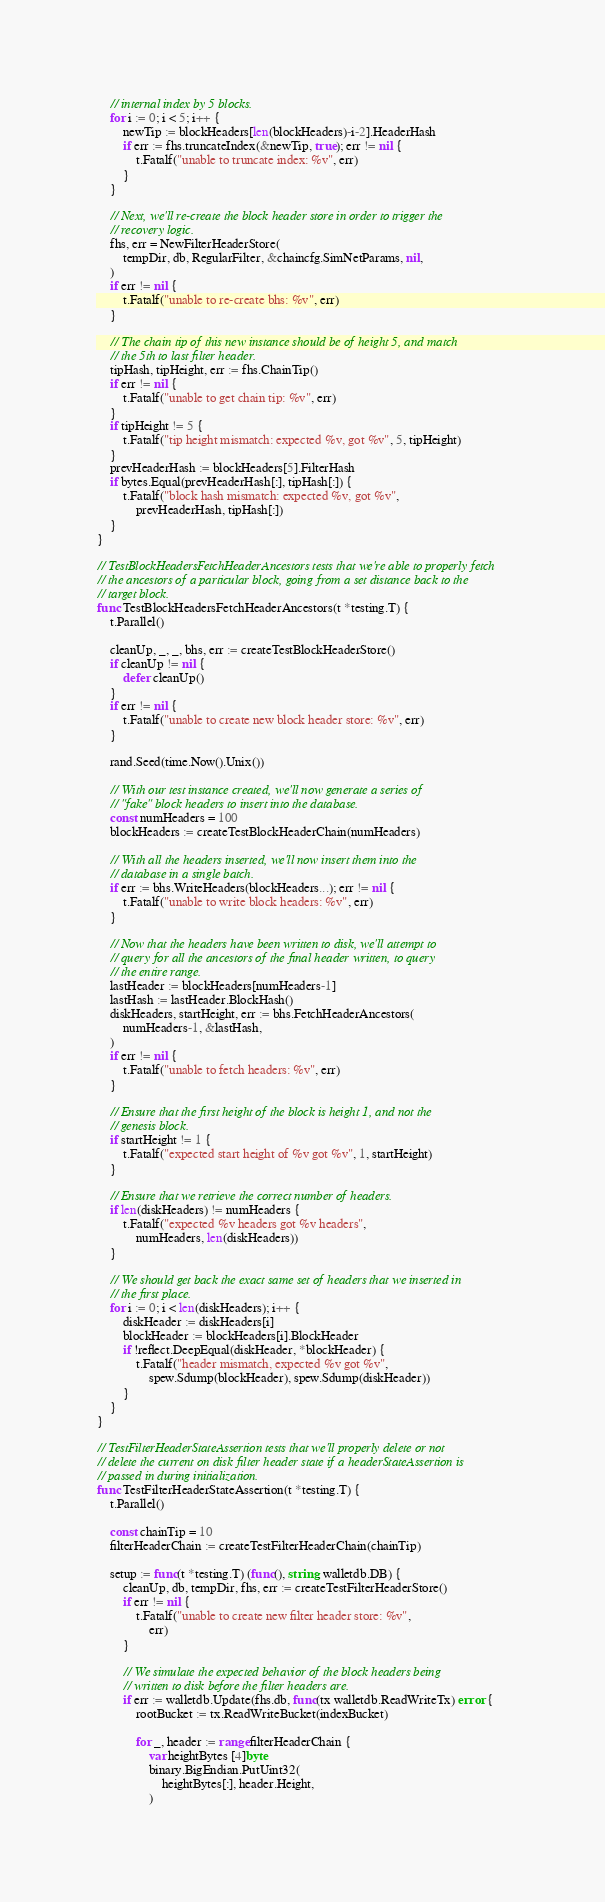Convert code to text. <code><loc_0><loc_0><loc_500><loc_500><_Go_>	// internal index by 5 blocks.
	for i := 0; i < 5; i++ {
		newTip := blockHeaders[len(blockHeaders)-i-2].HeaderHash
		if err := fhs.truncateIndex(&newTip, true); err != nil {
			t.Fatalf("unable to truncate index: %v", err)
		}
	}

	// Next, we'll re-create the block header store in order to trigger the
	// recovery logic.
	fhs, err = NewFilterHeaderStore(
		tempDir, db, RegularFilter, &chaincfg.SimNetParams, nil,
	)
	if err != nil {
		t.Fatalf("unable to re-create bhs: %v", err)
	}

	// The chain tip of this new instance should be of height 5, and match
	// the 5th to last filter header.
	tipHash, tipHeight, err := fhs.ChainTip()
	if err != nil {
		t.Fatalf("unable to get chain tip: %v", err)
	}
	if tipHeight != 5 {
		t.Fatalf("tip height mismatch: expected %v, got %v", 5, tipHeight)
	}
	prevHeaderHash := blockHeaders[5].FilterHash
	if bytes.Equal(prevHeaderHash[:], tipHash[:]) {
		t.Fatalf("block hash mismatch: expected %v, got %v",
			prevHeaderHash, tipHash[:])
	}
}

// TestBlockHeadersFetchHeaderAncestors tests that we're able to properly fetch
// the ancestors of a particular block, going from a set distance back to the
// target block.
func TestBlockHeadersFetchHeaderAncestors(t *testing.T) {
	t.Parallel()

	cleanUp, _, _, bhs, err := createTestBlockHeaderStore()
	if cleanUp != nil {
		defer cleanUp()
	}
	if err != nil {
		t.Fatalf("unable to create new block header store: %v", err)
	}

	rand.Seed(time.Now().Unix())

	// With our test instance created, we'll now generate a series of
	// "fake" block headers to insert into the database.
	const numHeaders = 100
	blockHeaders := createTestBlockHeaderChain(numHeaders)

	// With all the headers inserted, we'll now insert them into the
	// database in a single batch.
	if err := bhs.WriteHeaders(blockHeaders...); err != nil {
		t.Fatalf("unable to write block headers: %v", err)
	}

	// Now that the headers have been written to disk, we'll attempt to
	// query for all the ancestors of the final header written, to query
	// the entire range.
	lastHeader := blockHeaders[numHeaders-1]
	lastHash := lastHeader.BlockHash()
	diskHeaders, startHeight, err := bhs.FetchHeaderAncestors(
		numHeaders-1, &lastHash,
	)
	if err != nil {
		t.Fatalf("unable to fetch headers: %v", err)
	}

	// Ensure that the first height of the block is height 1, and not the
	// genesis block.
	if startHeight != 1 {
		t.Fatalf("expected start height of %v got %v", 1, startHeight)
	}

	// Ensure that we retrieve the correct number of headers.
	if len(diskHeaders) != numHeaders {
		t.Fatalf("expected %v headers got %v headers",
			numHeaders, len(diskHeaders))
	}

	// We should get back the exact same set of headers that we inserted in
	// the first place.
	for i := 0; i < len(diskHeaders); i++ {
		diskHeader := diskHeaders[i]
		blockHeader := blockHeaders[i].BlockHeader
		if !reflect.DeepEqual(diskHeader, *blockHeader) {
			t.Fatalf("header mismatch, expected %v got %v",
				spew.Sdump(blockHeader), spew.Sdump(diskHeader))
		}
	}
}

// TestFilterHeaderStateAssertion tests that we'll properly delete or not
// delete the current on disk filter header state if a headerStateAssertion is
// passed in during initialization.
func TestFilterHeaderStateAssertion(t *testing.T) {
	t.Parallel()

	const chainTip = 10
	filterHeaderChain := createTestFilterHeaderChain(chainTip)

	setup := func(t *testing.T) (func(), string, walletdb.DB) {
		cleanUp, db, tempDir, fhs, err := createTestFilterHeaderStore()
		if err != nil {
			t.Fatalf("unable to create new filter header store: %v",
				err)
		}

		// We simulate the expected behavior of the block headers being
		// written to disk before the filter headers are.
		if err := walletdb.Update(fhs.db, func(tx walletdb.ReadWriteTx) error {
			rootBucket := tx.ReadWriteBucket(indexBucket)

			for _, header := range filterHeaderChain {
				var heightBytes [4]byte
				binary.BigEndian.PutUint32(
					heightBytes[:], header.Height,
				)</code> 